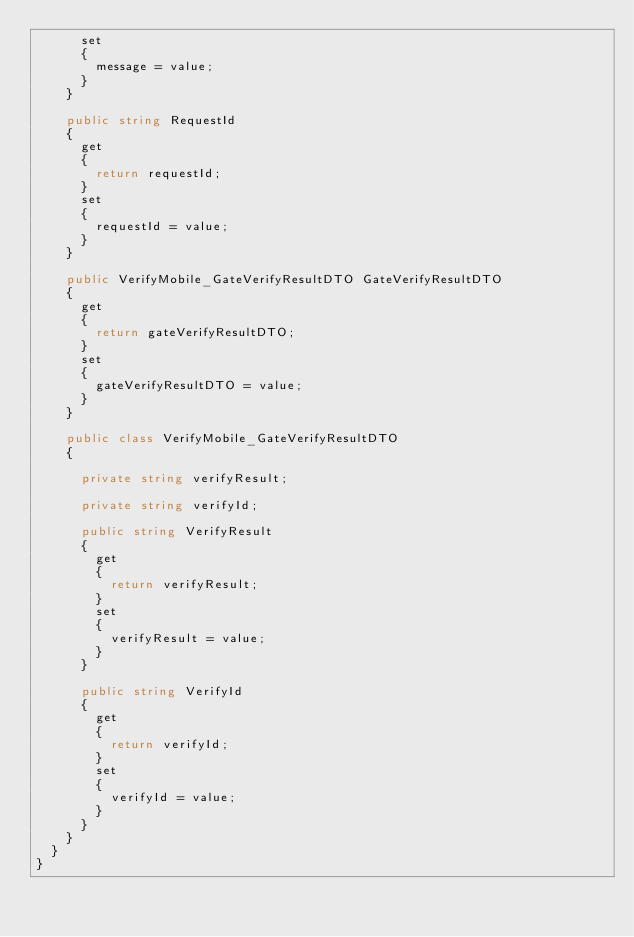Convert code to text. <code><loc_0><loc_0><loc_500><loc_500><_C#_>			set	
			{
				message = value;
			}
		}

		public string RequestId
		{
			get
			{
				return requestId;
			}
			set	
			{
				requestId = value;
			}
		}

		public VerifyMobile_GateVerifyResultDTO GateVerifyResultDTO
		{
			get
			{
				return gateVerifyResultDTO;
			}
			set	
			{
				gateVerifyResultDTO = value;
			}
		}

		public class VerifyMobile_GateVerifyResultDTO
		{

			private string verifyResult;

			private string verifyId;

			public string VerifyResult
			{
				get
				{
					return verifyResult;
				}
				set	
				{
					verifyResult = value;
				}
			}

			public string VerifyId
			{
				get
				{
					return verifyId;
				}
				set	
				{
					verifyId = value;
				}
			}
		}
	}
}
</code> 